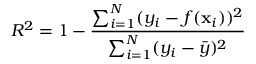<formula> <loc_0><loc_0><loc_500><loc_500>R ^ { 2 } = 1 - \frac { \sum _ { i = 1 } ^ { N } ( y _ { i } - f ( x _ { i } ) ) ^ { 2 } } { \sum _ { i = 1 } ^ { N } ( y _ { i } - \bar { y } ) ^ { 2 } }</formula> 